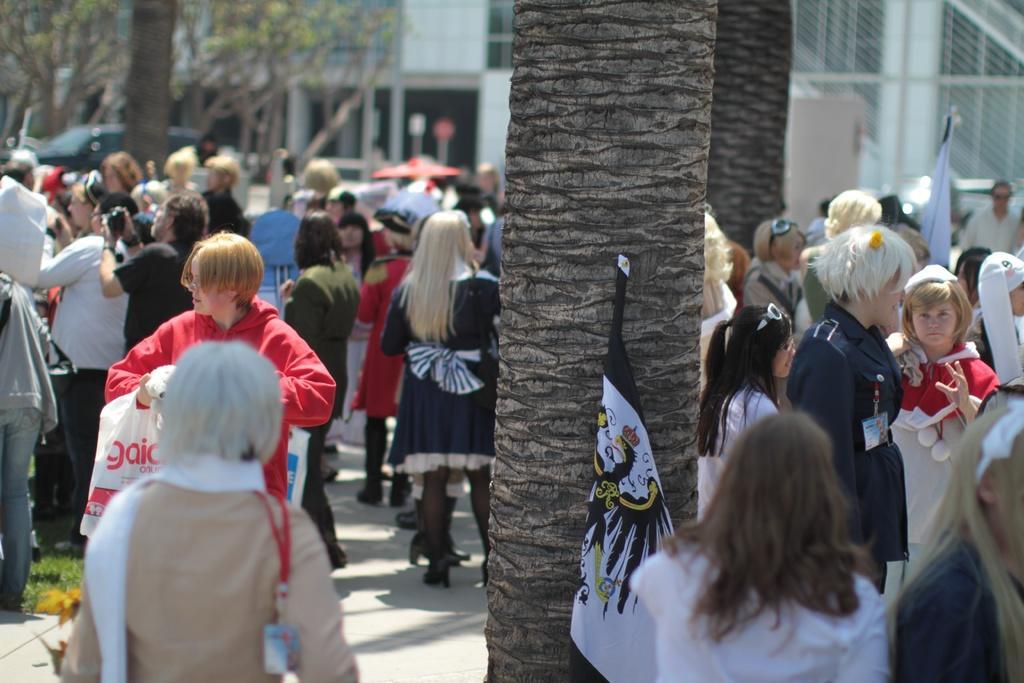Can you describe this image briefly? In this picture I can see group of people standing. There are trees, flags, and in the background there is a building. 